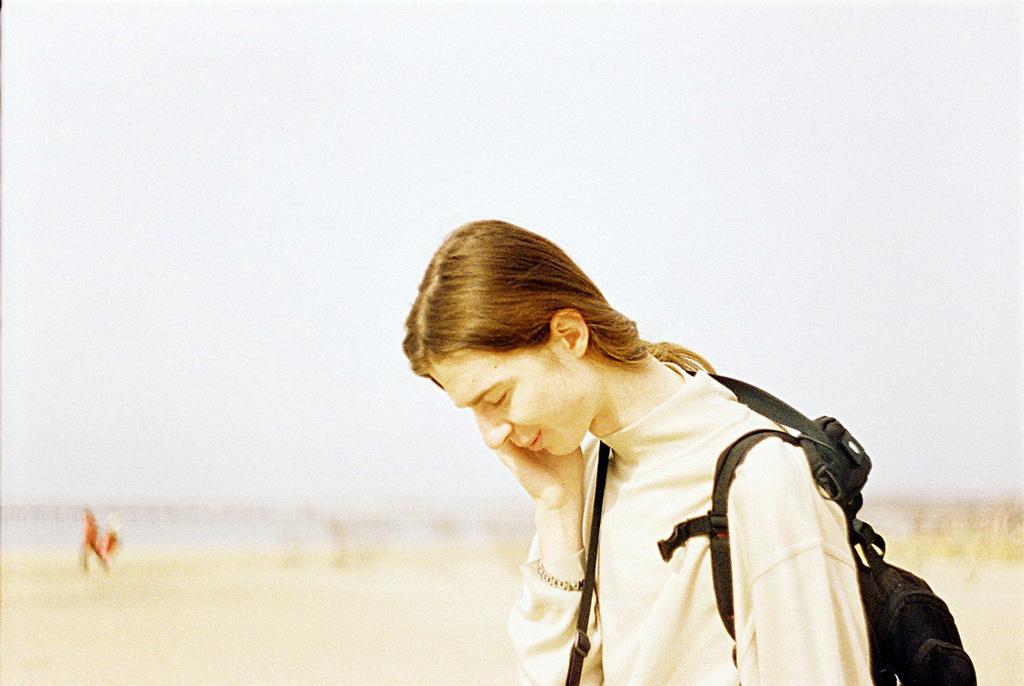What is the main subject of the image? There is a person in the image. What is the person wearing in the image? The person is wearing a bag. Can you describe the background of the image? The background of the image is blurry. How many clovers can be seen growing in the image? There are no clovers visible in the image; the background is blurry. 